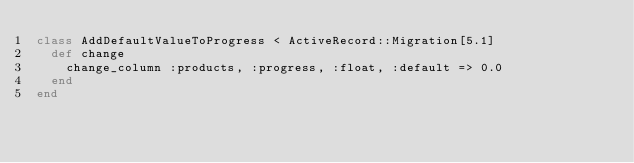Convert code to text. <code><loc_0><loc_0><loc_500><loc_500><_Ruby_>class AddDefaultValueToProgress < ActiveRecord::Migration[5.1]
  def change
    change_column :products, :progress, :float, :default => 0.0
  end
end
</code> 